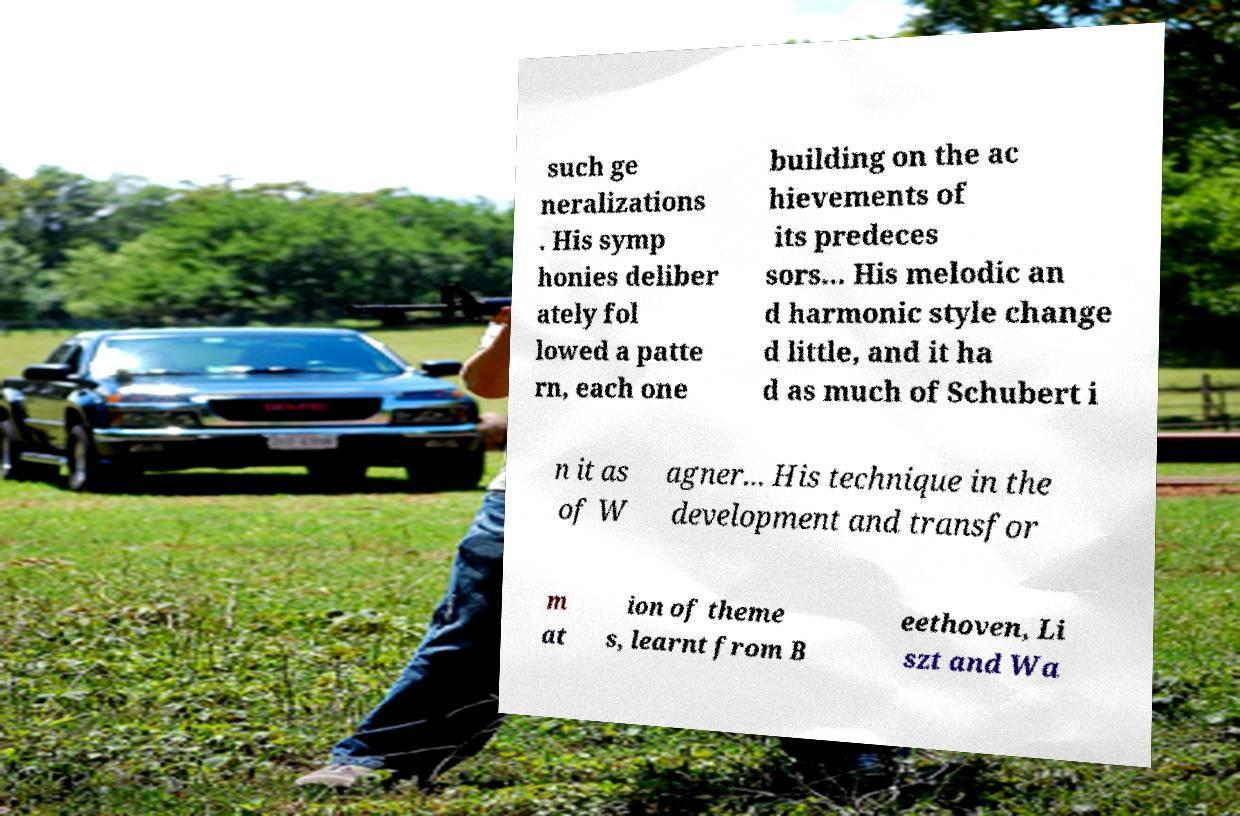I need the written content from this picture converted into text. Can you do that? such ge neralizations . His symp honies deliber ately fol lowed a patte rn, each one building on the ac hievements of its predeces sors... His melodic an d harmonic style change d little, and it ha d as much of Schubert i n it as of W agner... His technique in the development and transfor m at ion of theme s, learnt from B eethoven, Li szt and Wa 